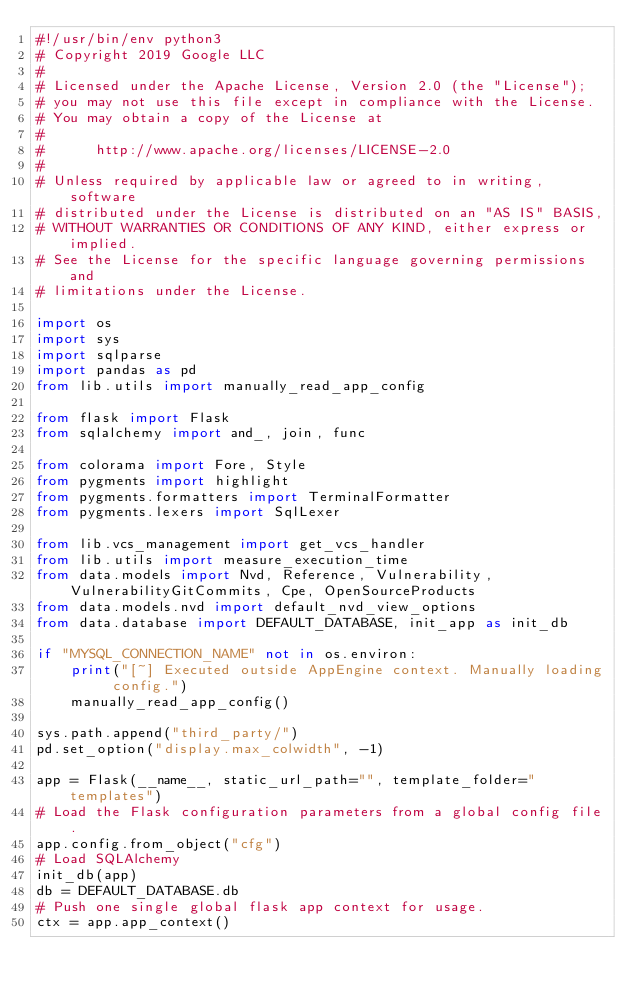Convert code to text. <code><loc_0><loc_0><loc_500><loc_500><_Python_>#!/usr/bin/env python3
# Copyright 2019 Google LLC
#
# Licensed under the Apache License, Version 2.0 (the "License");
# you may not use this file except in compliance with the License.
# You may obtain a copy of the License at
#
#      http://www.apache.org/licenses/LICENSE-2.0
#
# Unless required by applicable law or agreed to in writing, software
# distributed under the License is distributed on an "AS IS" BASIS,
# WITHOUT WARRANTIES OR CONDITIONS OF ANY KIND, either express or implied.
# See the License for the specific language governing permissions and
# limitations under the License.

import os
import sys
import sqlparse
import pandas as pd
from lib.utils import manually_read_app_config

from flask import Flask
from sqlalchemy import and_, join, func

from colorama import Fore, Style
from pygments import highlight
from pygments.formatters import TerminalFormatter
from pygments.lexers import SqlLexer

from lib.vcs_management import get_vcs_handler
from lib.utils import measure_execution_time
from data.models import Nvd, Reference, Vulnerability, VulnerabilityGitCommits, Cpe, OpenSourceProducts
from data.models.nvd import default_nvd_view_options
from data.database import DEFAULT_DATABASE, init_app as init_db

if "MYSQL_CONNECTION_NAME" not in os.environ:
    print("[~] Executed outside AppEngine context. Manually loading config.")
    manually_read_app_config()

sys.path.append("third_party/")
pd.set_option("display.max_colwidth", -1)

app = Flask(__name__, static_url_path="", template_folder="templates")
# Load the Flask configuration parameters from a global config file.
app.config.from_object("cfg")
# Load SQLAlchemy
init_db(app)
db = DEFAULT_DATABASE.db
# Push one single global flask app context for usage.
ctx = app.app_context()</code> 